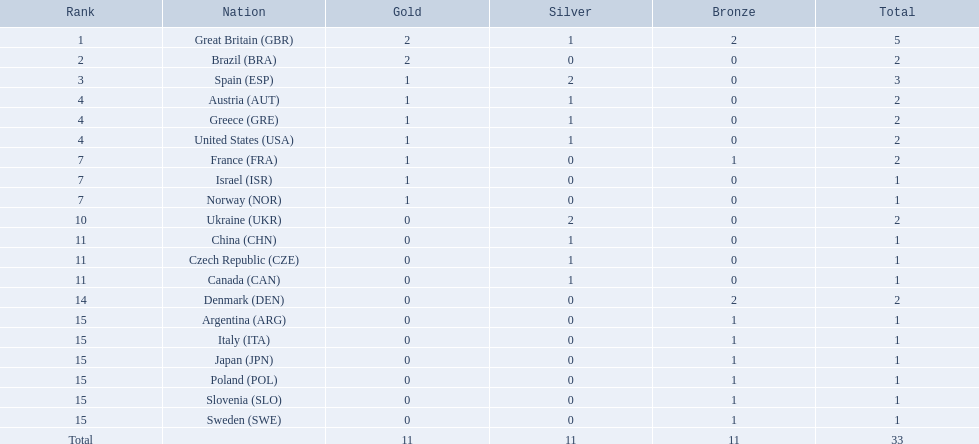Which country obtained 2 silver medals? Spain (ESP), Ukraine (UKR). Of those, which country also had 2 overall medals? Spain (ESP). 